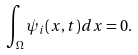Convert formula to latex. <formula><loc_0><loc_0><loc_500><loc_500>\int _ { \Omega } \psi _ { i } ( x , t ) d x = 0 .</formula> 